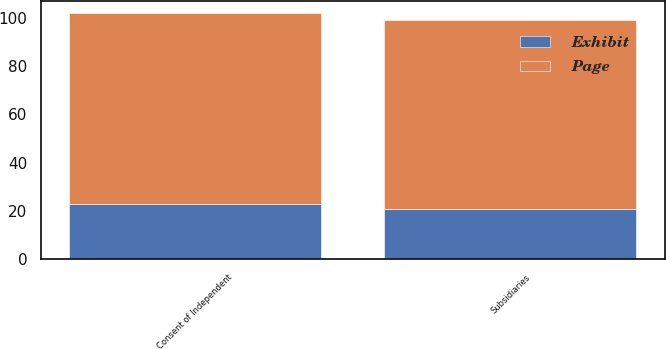Convert chart to OTSL. <chart><loc_0><loc_0><loc_500><loc_500><stacked_bar_chart><ecel><fcel>Subsidiaries<fcel>Consent of Independent<nl><fcel>Exhibit<fcel>21<fcel>23<nl><fcel>Page<fcel>78<fcel>79<nl></chart> 